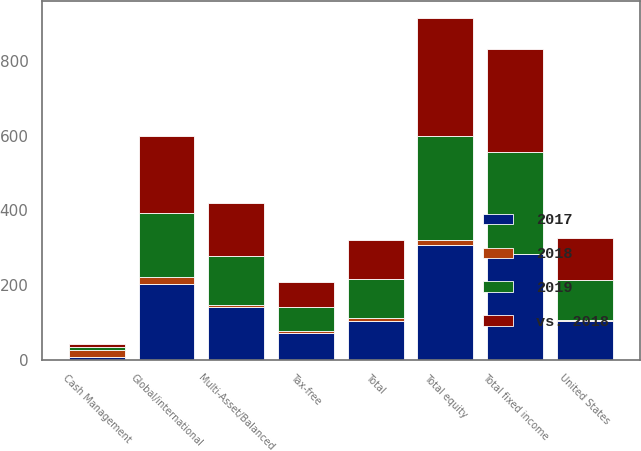Convert chart. <chart><loc_0><loc_0><loc_500><loc_500><stacked_bar_chart><ecel><fcel>Global/international<fcel>United States<fcel>Total equity<fcel>Multi-Asset/Balanced<fcel>Tax-free<fcel>Total fixed income<fcel>Cash Management<fcel>Total<nl><fcel>2019<fcel>171.7<fcel>109<fcel>280.7<fcel>133.4<fcel>63.9<fcel>273.4<fcel>9.5<fcel>104.4<nl><fcel>vs. 2018<fcel>205.8<fcel>110.2<fcel>316<fcel>140.6<fcel>67.3<fcel>275.9<fcel>8<fcel>104.4<nl><fcel>2017<fcel>203.7<fcel>104.4<fcel>308.1<fcel>140.2<fcel>72.3<fcel>282.4<fcel>6.2<fcel>104.4<nl><fcel>2018<fcel>17<fcel>1<fcel>11<fcel>5<fcel>5<fcel>1<fcel>19<fcel>6<nl></chart> 